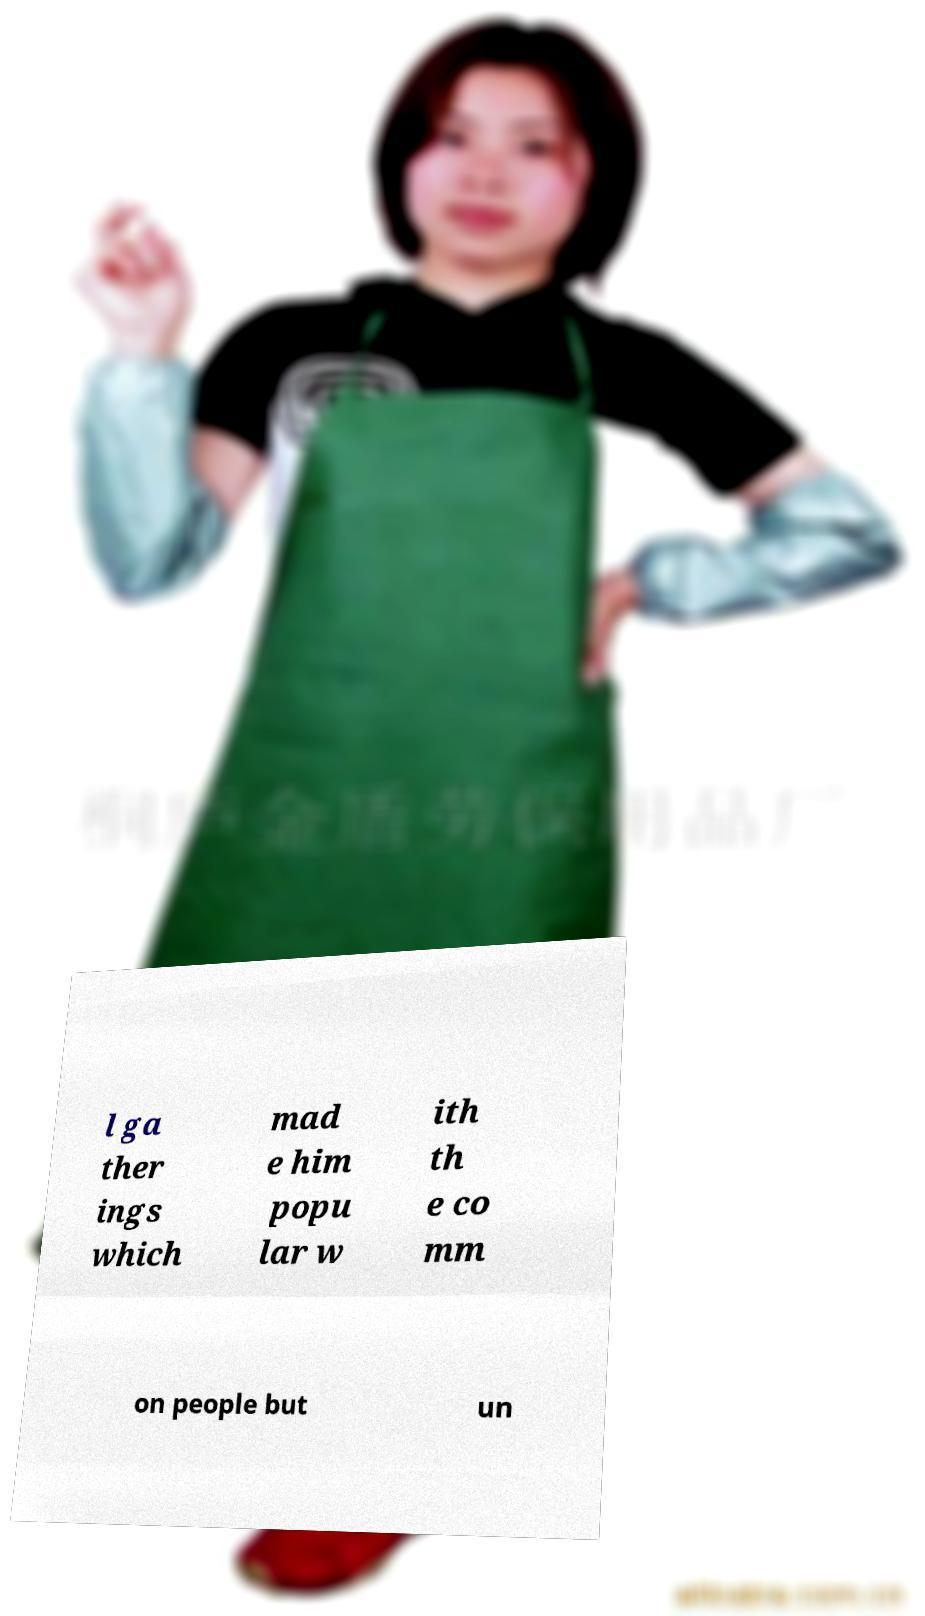Can you accurately transcribe the text from the provided image for me? l ga ther ings which mad e him popu lar w ith th e co mm on people but un 